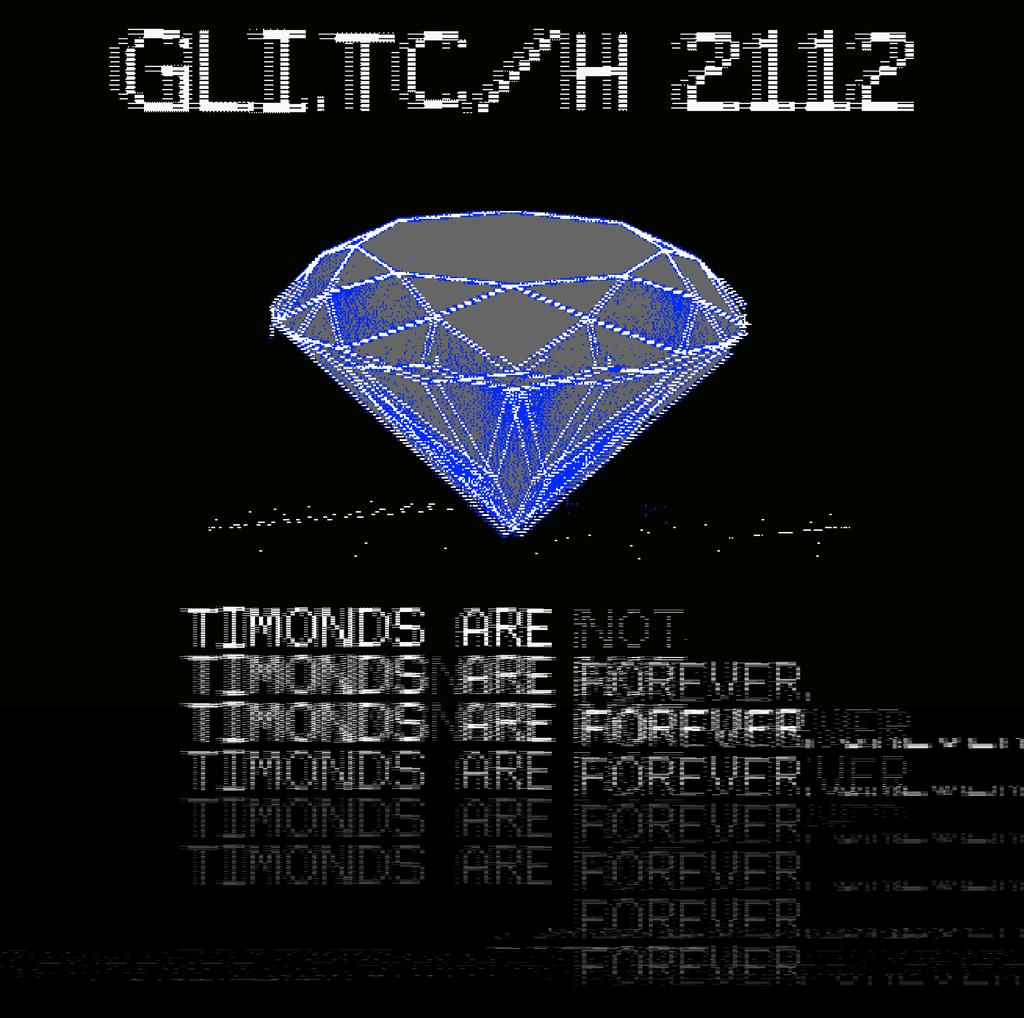Provide a one-sentence caption for the provided image. Computer screen of a glitch that diamonds are forever. 